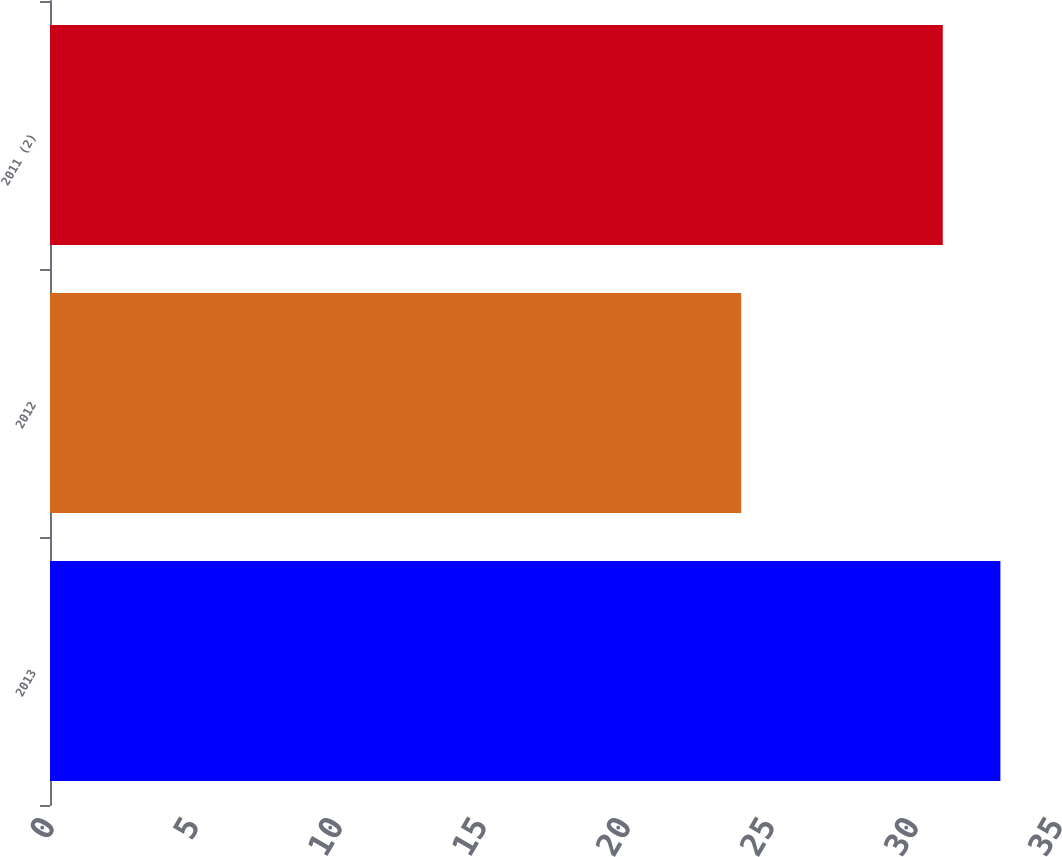<chart> <loc_0><loc_0><loc_500><loc_500><bar_chart><fcel>2013<fcel>2012<fcel>2011 (2)<nl><fcel>33<fcel>24<fcel>31<nl></chart> 